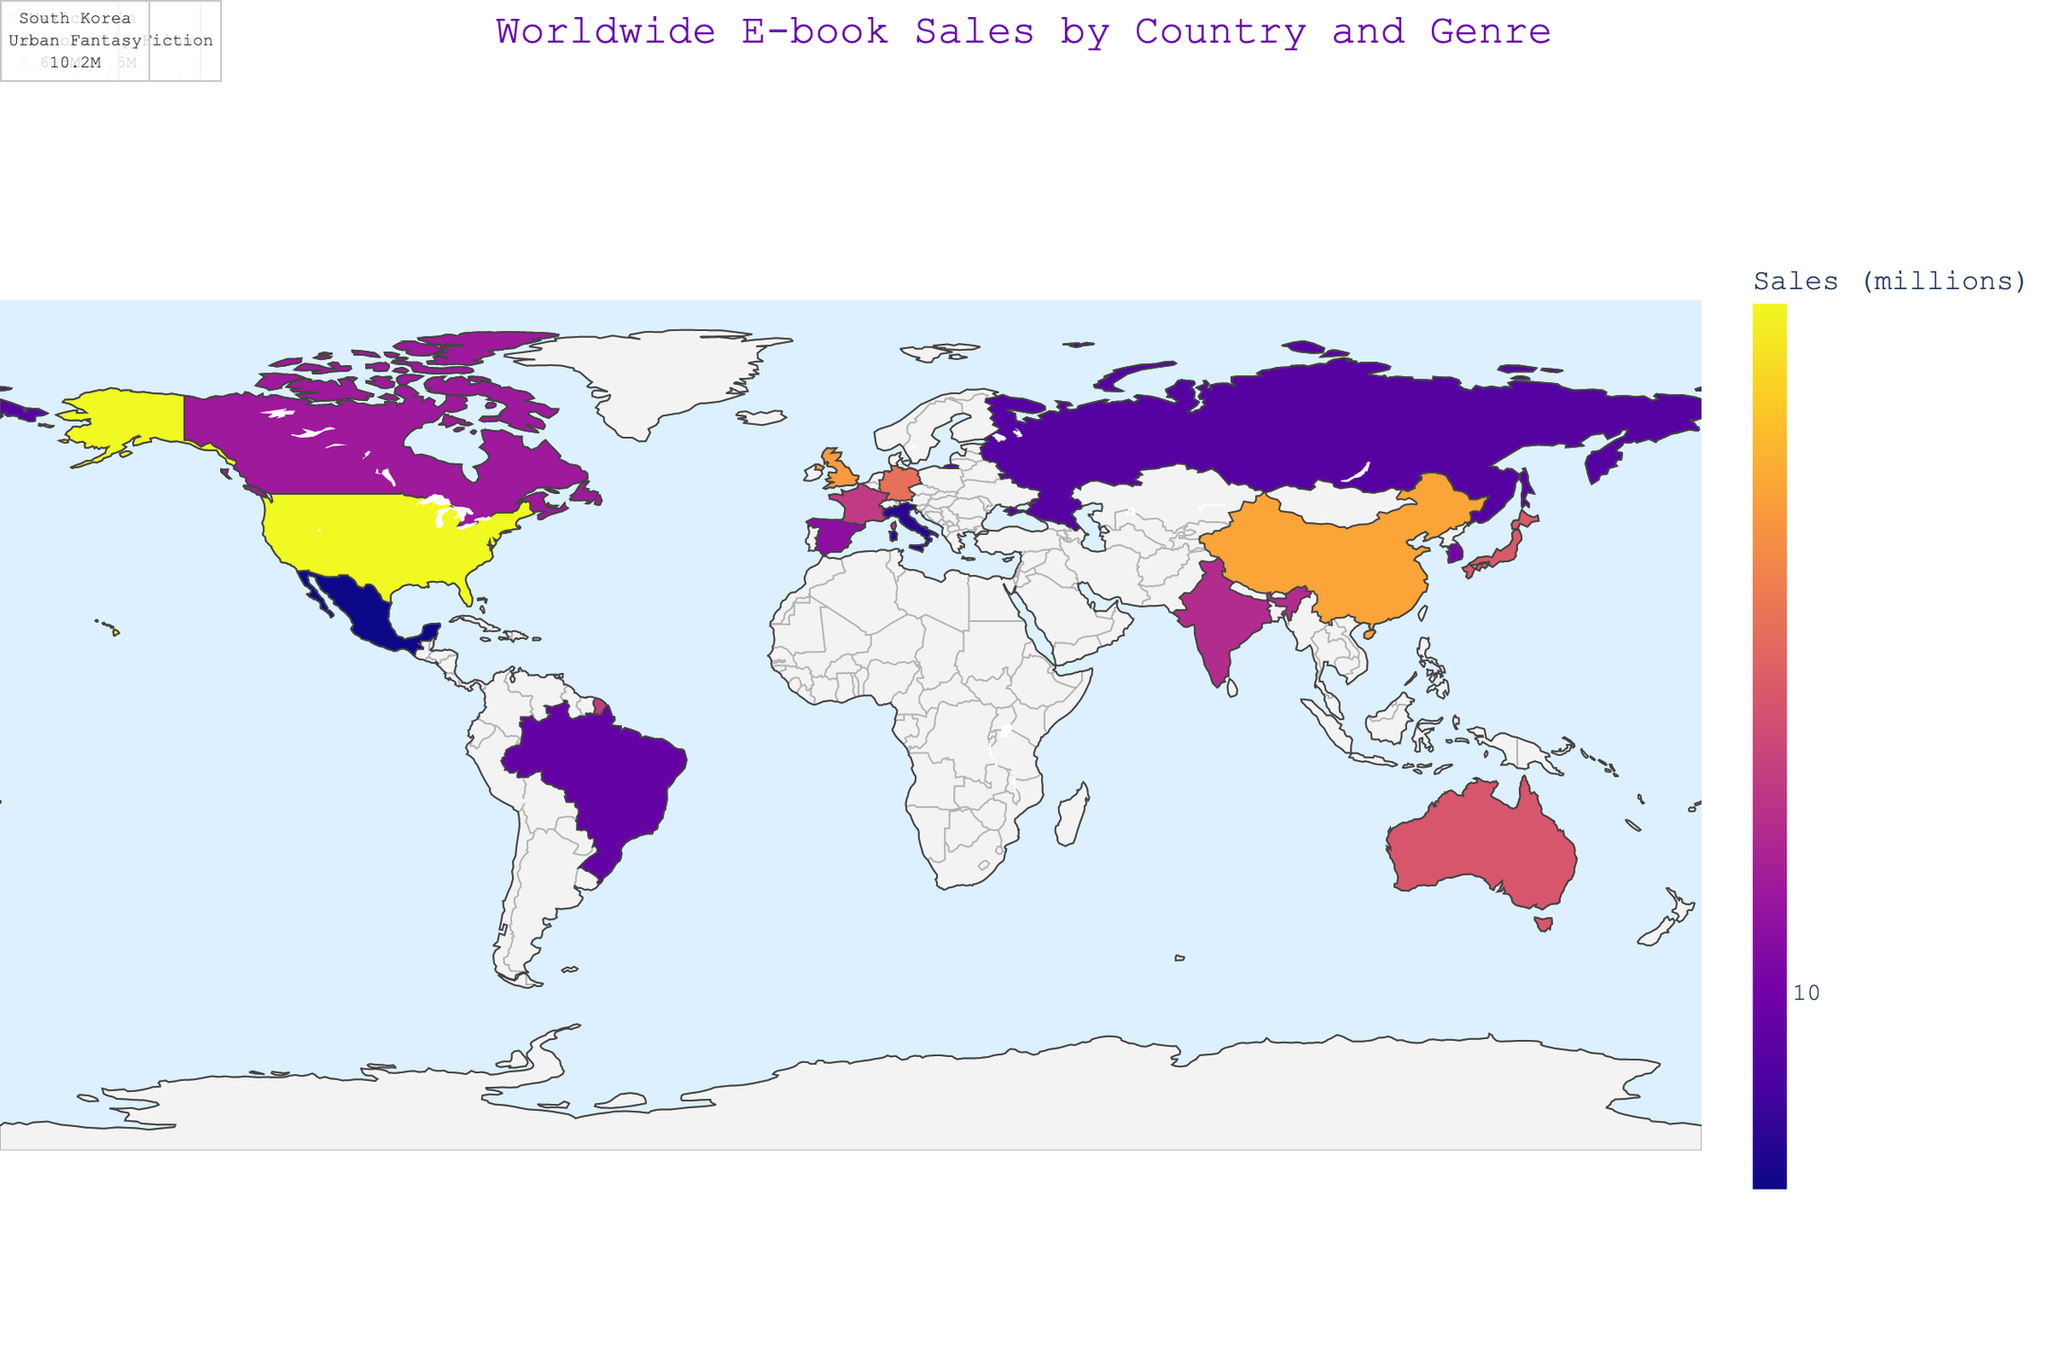Which country has the highest e-book sales? The figure demonstrates the log-transformed e-book sales for each country, where the larger the colored region, the higher the sales. The USA has the highest value.
Answer: USA What genre has the highest sales in the UK? By inspecting the hover data for the UK on the map, the genre with the highest sales is Romance.
Answer: Romance Compare the e-book sales of Japan and Germany. Which one is higher? By reviewing the hover data, Japan has 19.5 million sales in Science Fiction, and Germany has 22.3 million in Mystery. Thus, Germany's sales are higher.
Answer: Germany Which country has the least e-book sales? The color gradient on the map represents e-book sales, with lighter regions indicating lower sales. Mexico has the least sales with 6.5 million.
Answer: Mexico What is the sum of e-book sales for China and India? China has 30.1 million sales in Dystopian and India has 14.3 million in Adventure. Summing these values gives the total sales as 30.1 + 14.3 = 44.4 million.
Answer: 44.4 million What is the average e-book sales for the countries listed? To find the average, first sum the total sales of all countries and then divide by the number of countries. The total sales are 45.2 + 28.7 + 19.5 + 22.3 + 15.8 + 12.6 + 18.9 + 9.4 + 7.2 + 11.5 + 30.1 + 14.3 + 8.7 + 6.5 + 10.2 = 260.9 million. There are 15 countries, so the average is 260.9 / 15 = 17.39 million.
Answer: 17.39 million Which genre dominates e-book sales in South Korea? By looking at the hover data for South Korea, the genre with the highest sales is Urban Fantasy.
Answer: Urban Fantasy Compare the e-book sales of Thriller genre in Australia and the Science Fiction genre in Japan. Which one has more sales? Checking the hover data for Australia in Thriller (18.9 million) and Japan in Science Fiction (19.5 million) shows Japan has slightly more sales.
Answer: Japan What is the most popular genre in Spain? According to the hover data for Spain, the most popular genre is Contemporary Fiction.
Answer: Contemporary Fiction 